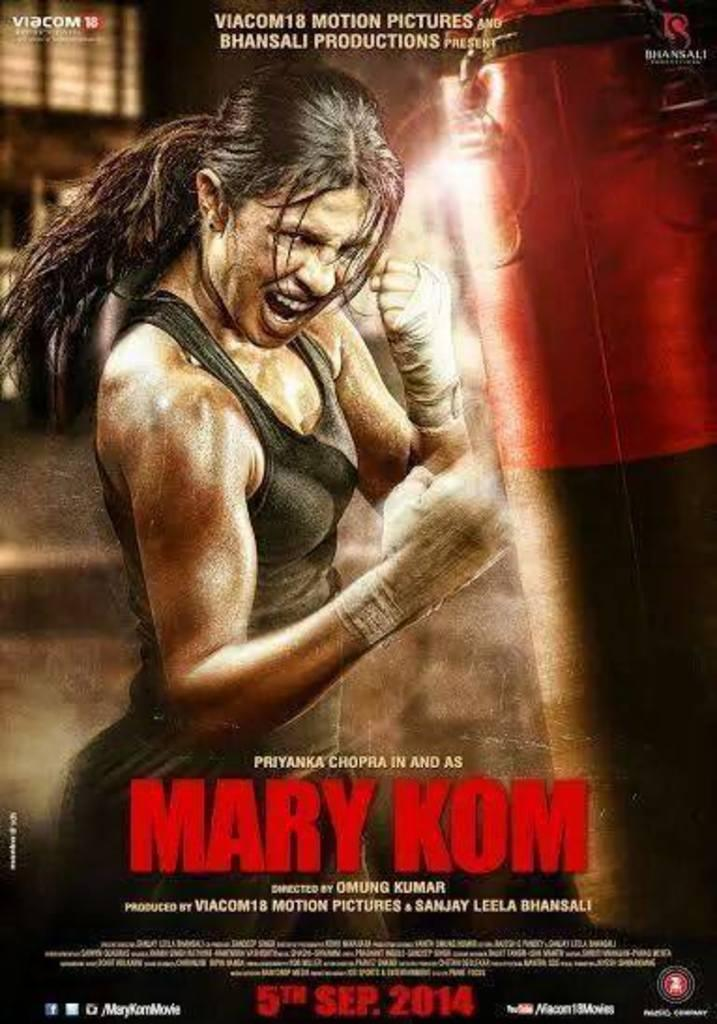<image>
Create a compact narrative representing the image presented. A movie poster with a girl in an angry fighting pose and has the words Mary Kom across it. 